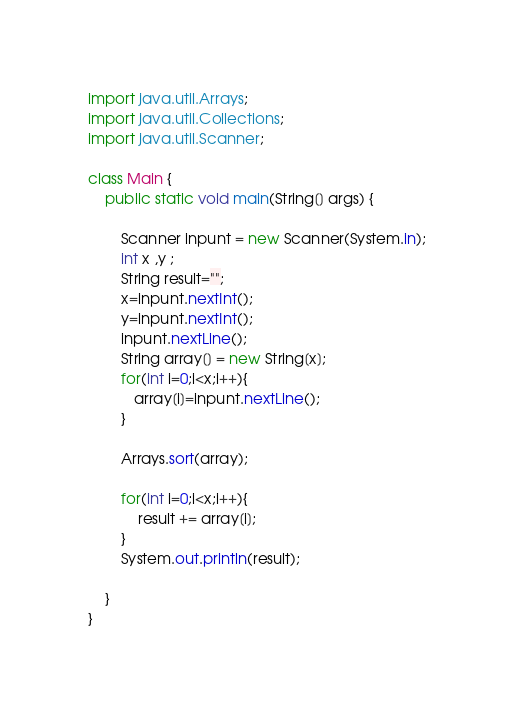Convert code to text. <code><loc_0><loc_0><loc_500><loc_500><_Java_>import java.util.Arrays;
import java.util.Collections;
import java.util.Scanner;

class Main {
    public static void main(String[] args) {

        Scanner inpunt = new Scanner(System.in);
        int x ,y ;
        String result="";
        x=inpunt.nextInt();
        y=inpunt.nextInt();
        inpunt.nextLine();
        String array[] = new String[x];
        for(int i=0;i<x;i++){
           array[i]=inpunt.nextLine();
        }

        Arrays.sort(array);

        for(int i=0;i<x;i++){
            result += array[i];
        }
        System.out.println(result);

    }
}</code> 